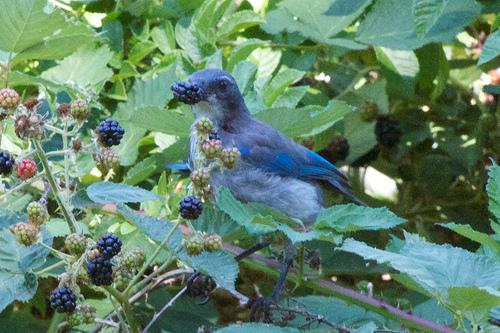Question: who can be seen in the picture?
Choices:
A. 1 man.
B. 1 woman.
C. No one.
D. 2 teenagers.
Answer with the letter. Answer: C Question: what is the bird doing?
Choices:
A. Flying.
B. Singing.
C. Swooping.
D. Eating berries.
Answer with the letter. Answer: D Question: where was the picture taken?
Choices:
A. By the bushes.
B. In the trees.
C. At the beach.
D. In a basement.
Answer with the letter. Answer: B Question: why was the picture taken?
Choices:
A. To capture the bird.
B. To document the nature scene.
C. For posterity.
D. To practice photography.
Answer with the letter. Answer: A Question: what color are the leaves?
Choices:
A. Blue.
B. Red.
C. Yellow.
D. Green.
Answer with the letter. Answer: D 